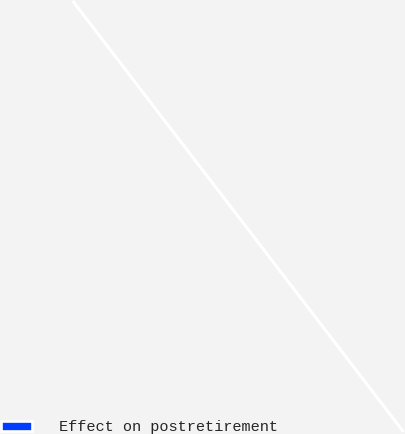<chart> <loc_0><loc_0><loc_500><loc_500><pie_chart><fcel>Effect on postretirement<nl><fcel>100.0%<nl></chart> 